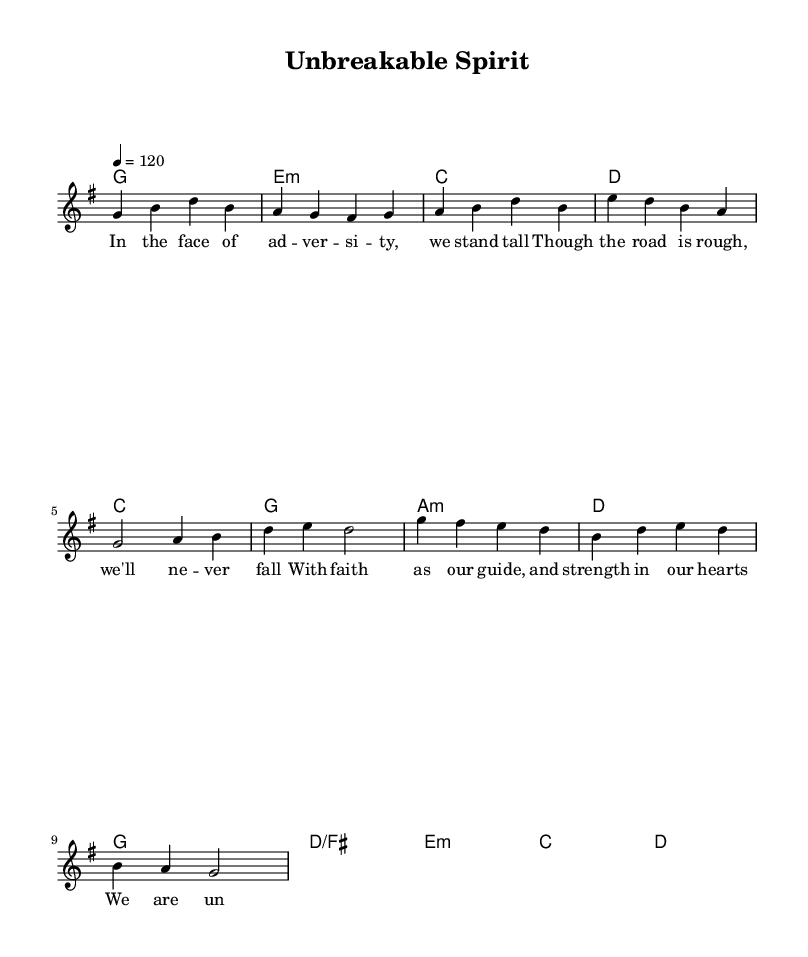What is the key signature of this music? The key signature is G major, indicated by one sharp (F#) in the music.
Answer: G major What is the time signature of this music? The time signature is 4/4, indicating four beats per measure.
Answer: 4/4 What is the tempo indicated in the music? The tempo is marked as quarter note equals 120 beats per minute, which defines how fast the music should be played.
Answer: 120 How many measures are in the verse section? The verse section is comprised of four measures, as counted in the melody notation.
Answer: 4 What is the main theme expressed in the lyrics of the verse? The main theme in the lyrics focuses on resilience and strength in the face of adversity, emphasizing an unbreakable spirit.
Answer: Resilience Which chord follows the G chord in the chorus? In the chorus, the G chord is followed by the D/F# chord as seen in the harmonies section.
Answer: D/F# What is the overall mood conveyed by the music? The music conveys an uplifting and hopeful mood, reflecting the theme of overcoming challenges through faith.
Answer: Uplifting 